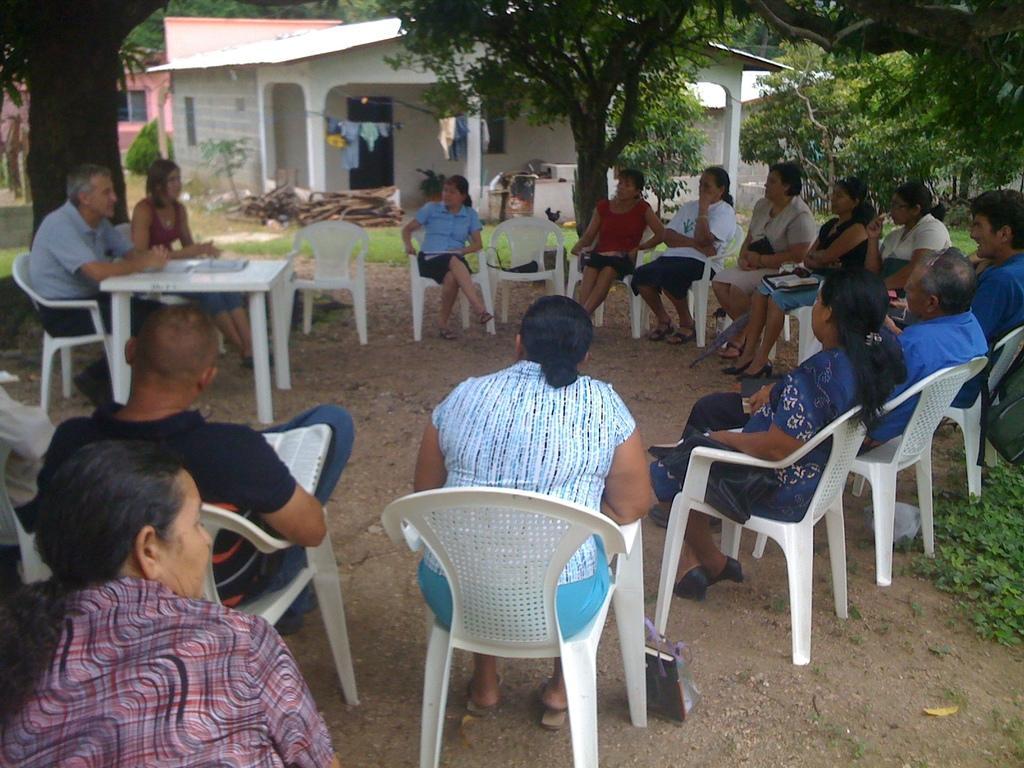Describe this image in one or two sentences. This is the out side of a house and there are the group of persons sitting on the chair and there are the two persons sitting in front of the table on the chair and there are the some trees visible and right side there is a house visible and in front of the house there are some clothes visible. 